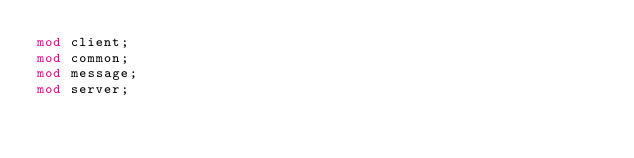<code> <loc_0><loc_0><loc_500><loc_500><_Rust_>mod client;
mod common;
mod message;
mod server;
</code> 